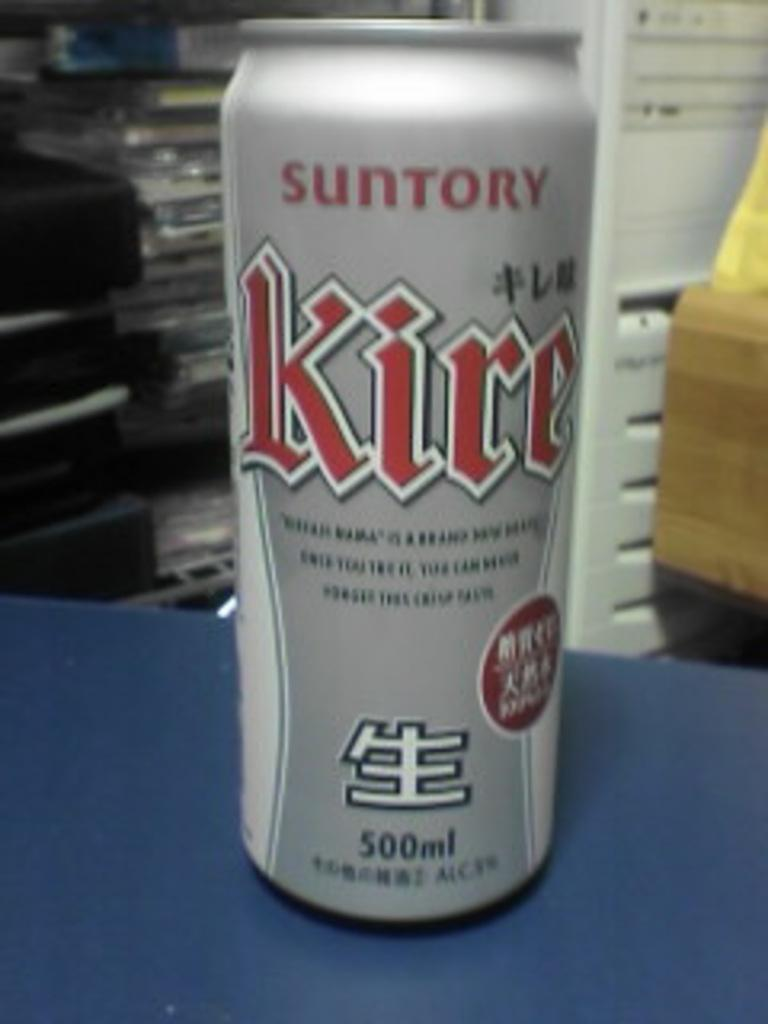<image>
Offer a succinct explanation of the picture presented. A silver can of Suntory Kire on a blue table. 